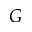Convert formula to latex. <formula><loc_0><loc_0><loc_500><loc_500>G</formula> 